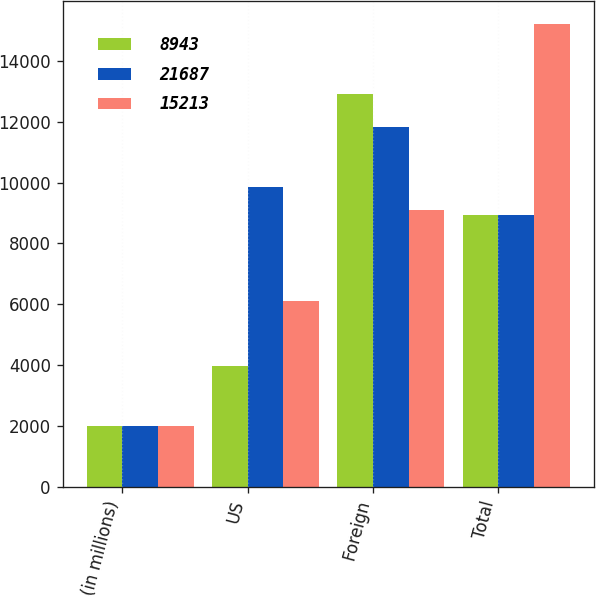Convert chart to OTSL. <chart><loc_0><loc_0><loc_500><loc_500><stacked_bar_chart><ecel><fcel>(in millions)<fcel>US<fcel>Foreign<fcel>Total<nl><fcel>8943<fcel>2007<fcel>3957<fcel>12900<fcel>8943<nl><fcel>21687<fcel>2006<fcel>9862<fcel>11825<fcel>8943<nl><fcel>15213<fcel>2005<fcel>6103<fcel>9110<fcel>15213<nl></chart> 